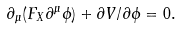<formula> <loc_0><loc_0><loc_500><loc_500>\partial _ { \mu } ( F _ { X } \partial ^ { \mu } \phi ) + \partial V / \partial \phi = 0 .</formula> 